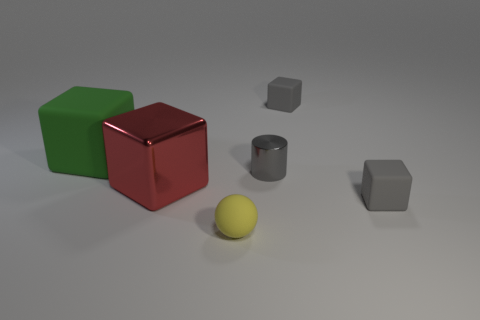Does the red shiny object have the same shape as the big green thing?
Give a very brief answer. Yes. There is a block that is in front of the metal block; does it have the same size as the rubber block that is on the left side of the tiny gray metallic cylinder?
Your answer should be compact. No. There is a object that is made of the same material as the tiny gray cylinder; what is its size?
Offer a terse response. Large. Are there any cubes of the same color as the small metallic object?
Provide a short and direct response. Yes. There is a yellow ball; is its size the same as the gray rubber object that is behind the tiny cylinder?
Provide a short and direct response. Yes. How many matte things are right of the matte cube that is to the left of the small gray matte cube that is behind the large red shiny thing?
Make the answer very short. 3. There is a metal block; are there any tiny cylinders on the right side of it?
Your answer should be very brief. Yes. There is a large red metallic object; what shape is it?
Make the answer very short. Cube. What shape is the tiny rubber thing that is left of the tiny rubber cube behind the tiny cube in front of the large red metallic object?
Offer a very short reply. Sphere. How many other things are the same shape as the yellow rubber object?
Your response must be concise. 0. 